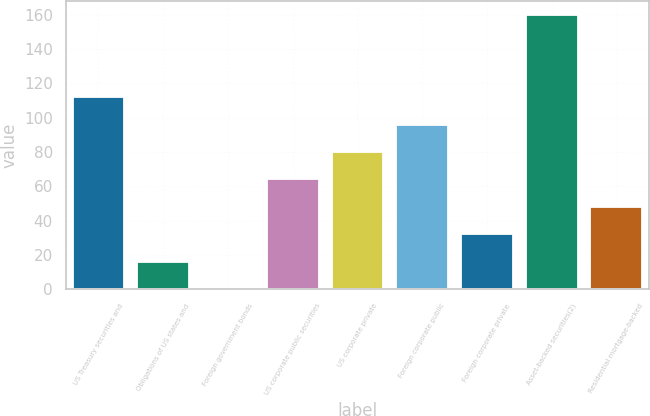<chart> <loc_0><loc_0><loc_500><loc_500><bar_chart><fcel>US Treasury securities and<fcel>Obligations of US states and<fcel>Foreign government bonds<fcel>US corporate public securities<fcel>US corporate private<fcel>Foreign corporate public<fcel>Foreign corporate private<fcel>Asset-backed securities(2)<fcel>Residential mortgage-backed<nl><fcel>112.03<fcel>16.15<fcel>0.17<fcel>64.09<fcel>80.07<fcel>96.05<fcel>32.13<fcel>160<fcel>48.11<nl></chart> 